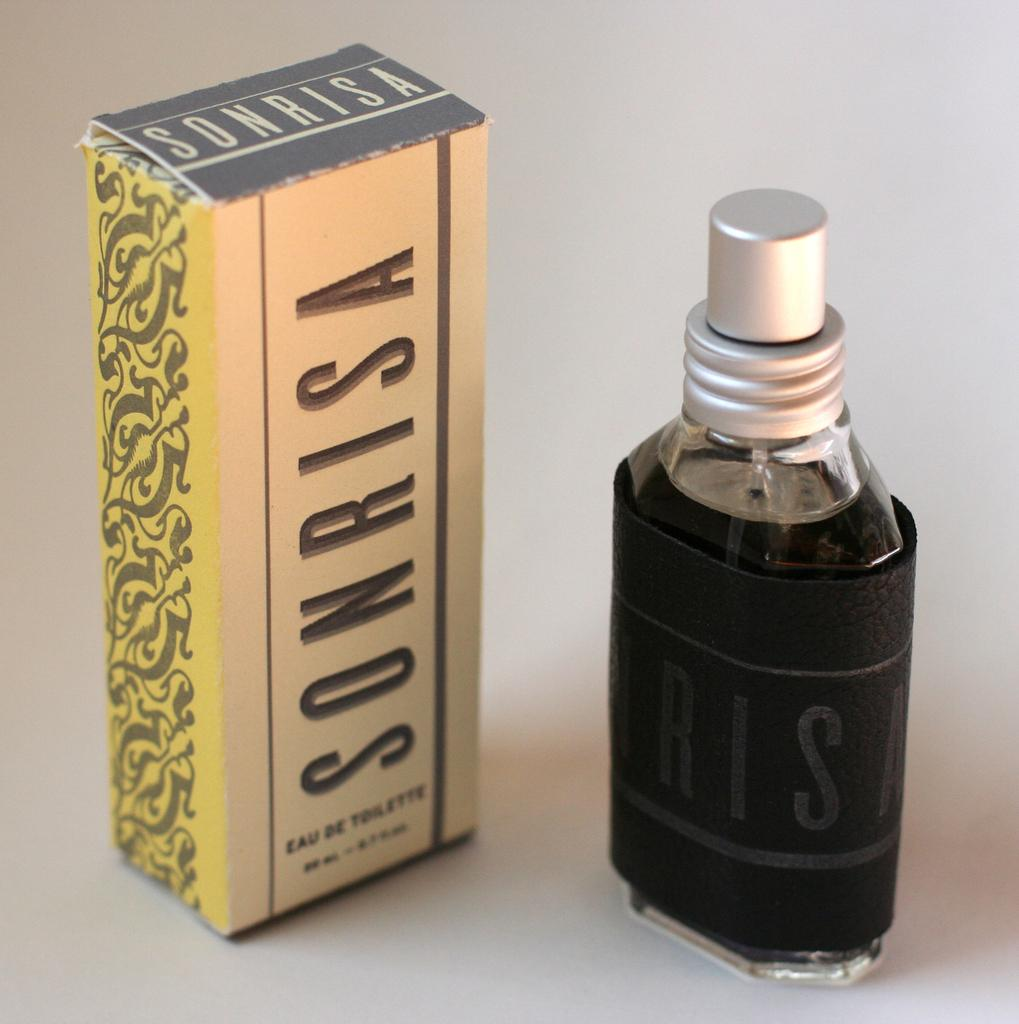<image>
Present a compact description of the photo's key features. a cologne item next to a sonrisa item 